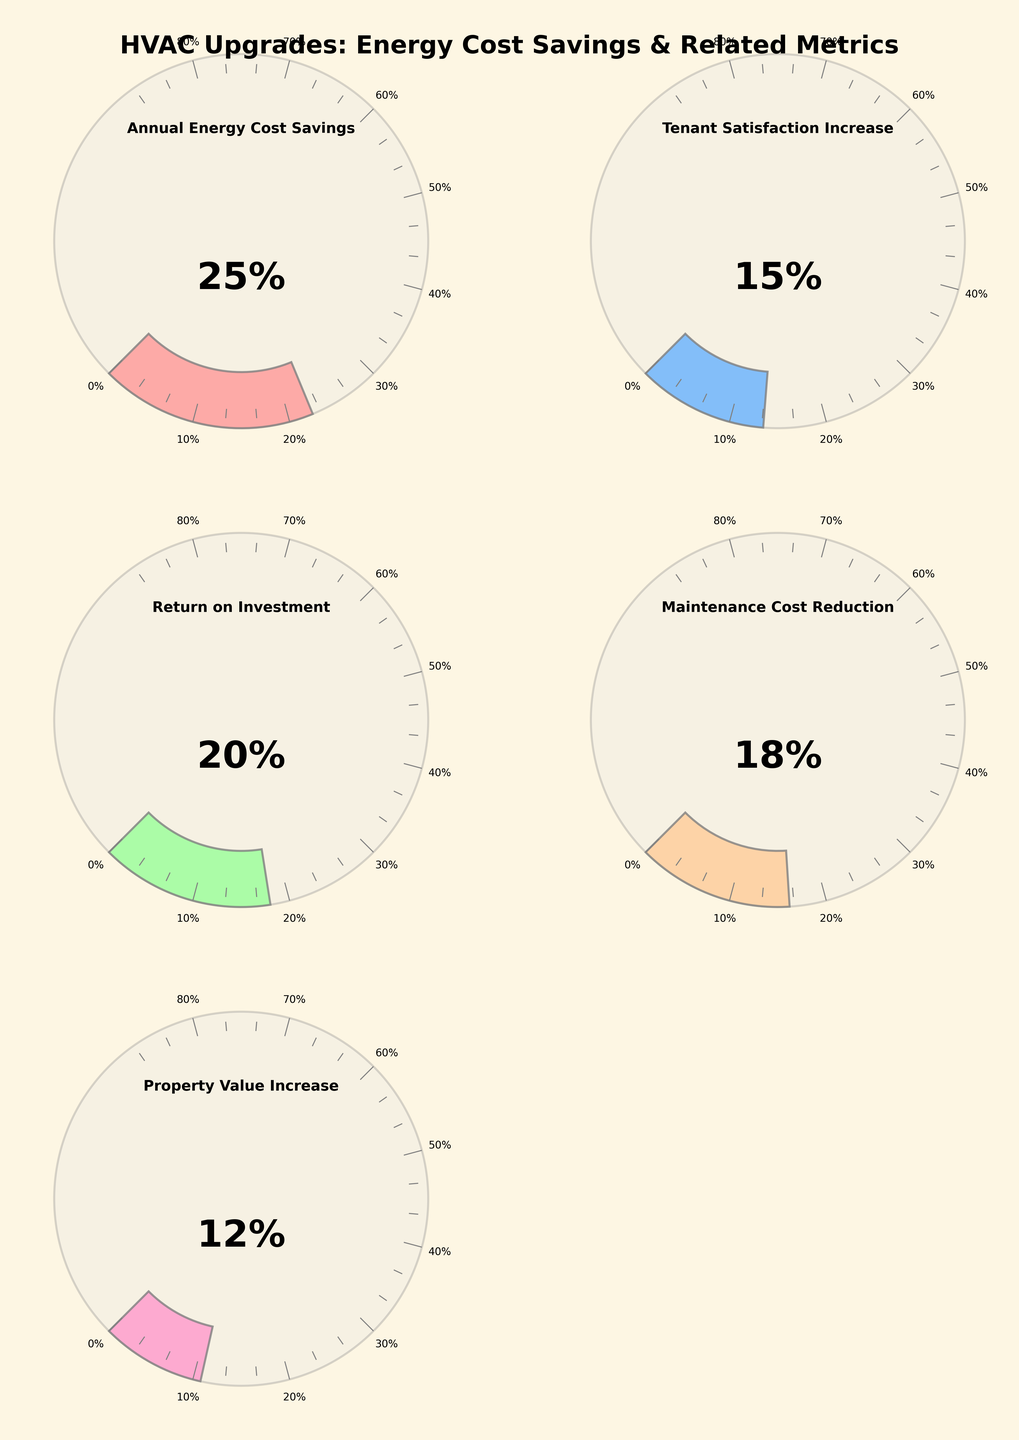What's the highest percentage achieved on the gauge charts? The highest percentage is displayed on the gauge showing "Annual Energy Cost Savings". According to this gauge, the needle points to 25%, which is the highest value among all other gauges.
Answer: 25% Which metric shows the lowest improvement percentage after HVAC upgrades? The lowest percentage indicated on the gauges is for "Property Value Increase", which stands at 12%. This can be observed as the gauge's needle is pointing to this value, which is less than all the other metrics.
Answer: 12% What is the return on investment percentage from the HVAC upgrades? The gauge labeled "Return on Investment" shows the percentage directly with the needle pointing towards 20%.
Answer: 20% How many metrics are displayed on the gauge charts? There are five different metrics displayed, each with its own gauge, covering "Annual Energy Cost Savings", "Tenant Satisfaction Increase", "Return on Investment", "Maintenance Cost Reduction", and "Property Value Increase".
Answer: 5 What's the average improvement percentage across all the metrics shown? To find the average, sum the percentages of all metrics: 25% + 15% + 20% + 18% + 12% = 90%. Then divide by the number of metrics, which is 5. Thus, 90% / 5 = 18%.
Answer: 18% Which metric has a greater improvement percentage, "Maintenance Cost Reduction" or "Tenant Satisfaction Increase"? By comparing the gauges directly, "Maintenance Cost Reduction" shows 18%, while "Tenant Satisfaction Increase" shows 15%. Therefore, "Maintenance Cost Reduction" has a greater improvement.
Answer: Maintenance Cost Reduction What is the total energy cost savings percentage if we combine "Annual Energy Cost Savings" and "Property Value Increase"? Adding the percentages for "Annual Energy Cost Savings" (25%) and "Property Value Increase" (12%), we get 25% + 12% = 37%.
Answer: 37% Is the "Maintenance Cost Reduction" percentage higher or lower than the "Return on Investment" percentage? By observing the gauges, "Maintenance Cost Reduction" shows 18%, and "Return on Investment" shows 20%. Therefore, "Maintenance Cost Reduction" is lower.
Answer: Lower Which metric shows an improvement percentage close to 20%? The "Return on Investment" metric shows an improvement percentage that is exactly 20%, which is the closest to the specified value.
Answer: Return on Investment 